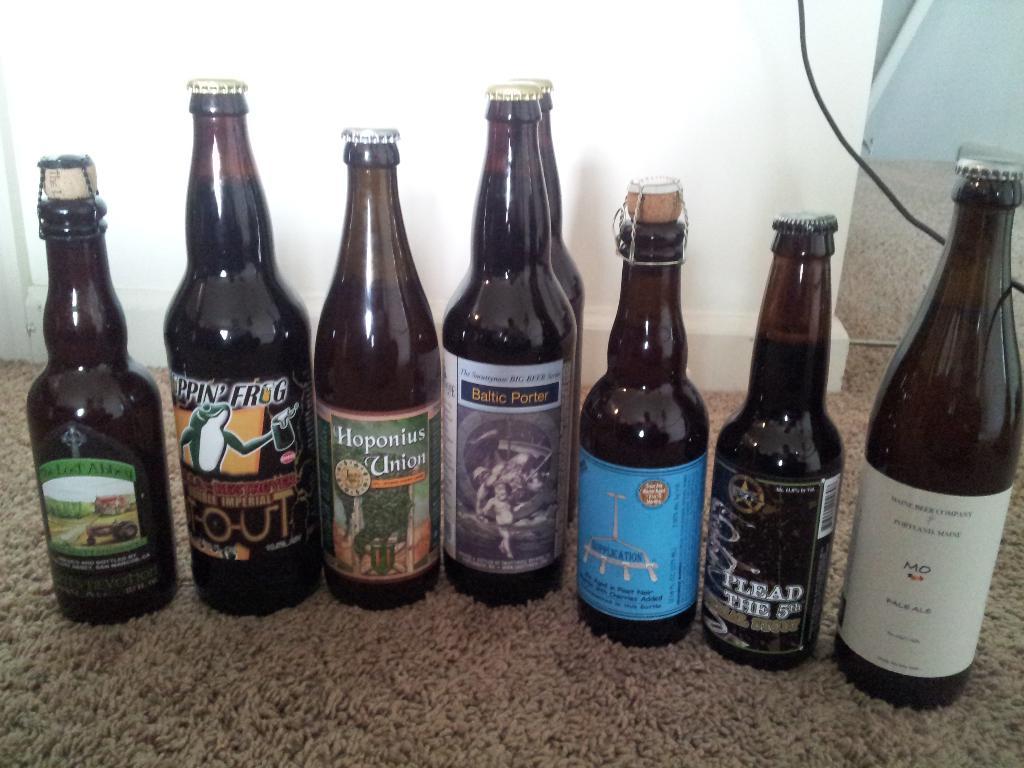What does the black label beer say?
Keep it short and to the point. Plead the 5th. 